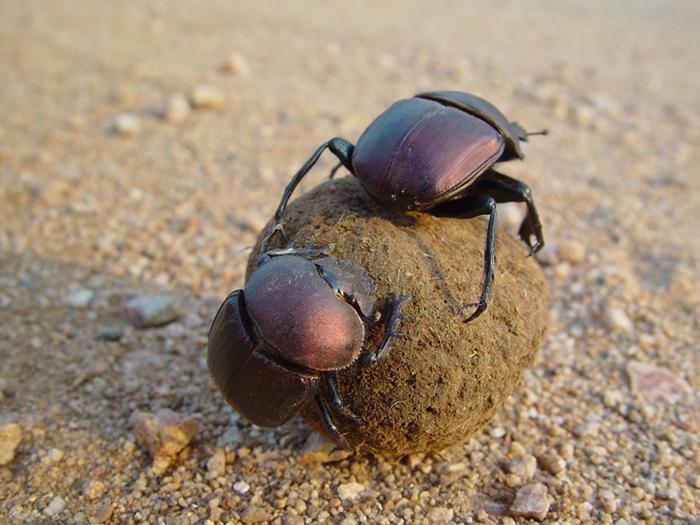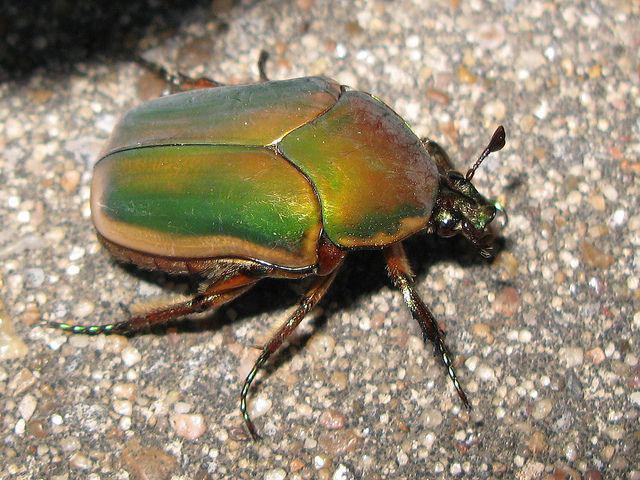The first image is the image on the left, the second image is the image on the right. Considering the images on both sides, is "There are two beetles on a clod of dirt in one of the images." valid? Answer yes or no. Yes. The first image is the image on the left, the second image is the image on the right. Considering the images on both sides, is "No rounded, dimensional shape is visible beneath the beetle in the right image." valid? Answer yes or no. Yes. 